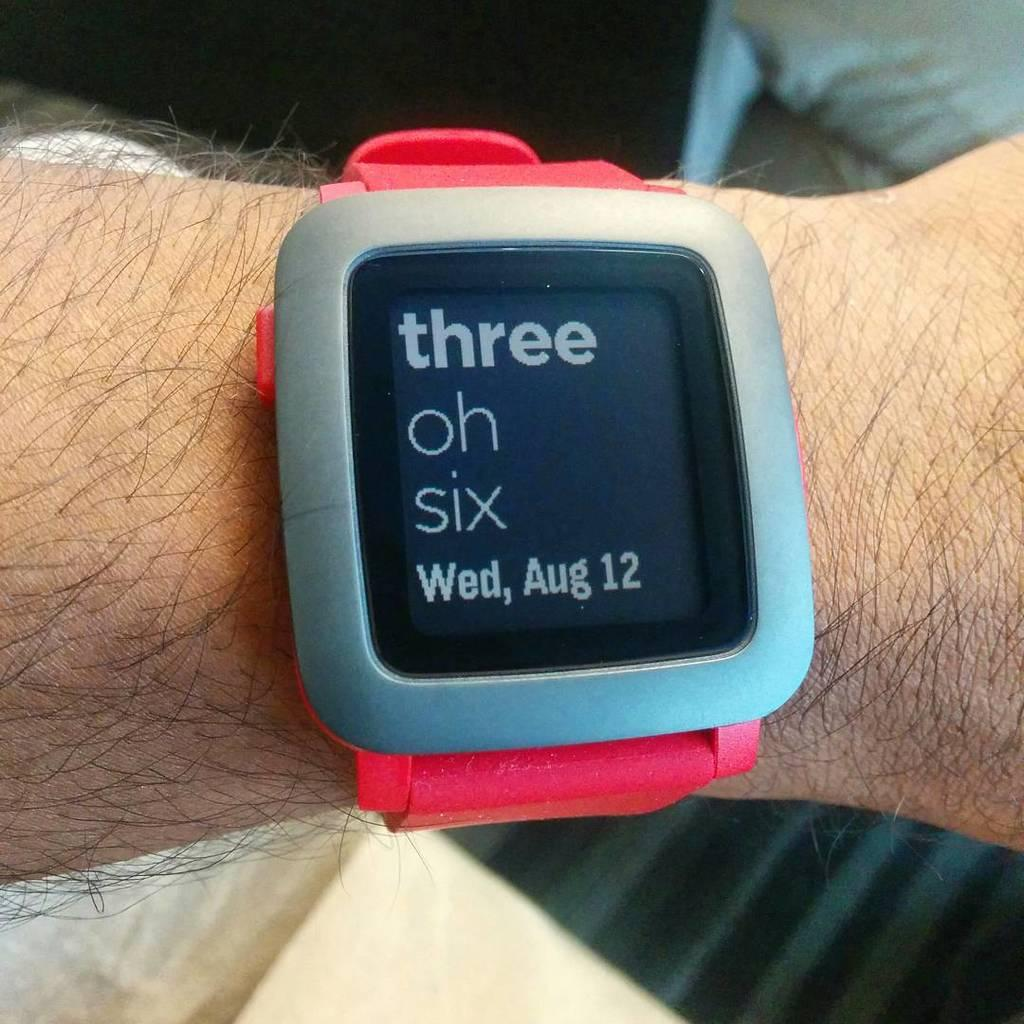<image>
Give a short and clear explanation of the subsequent image. A wrist watch with a red band with three oh six on the face. 